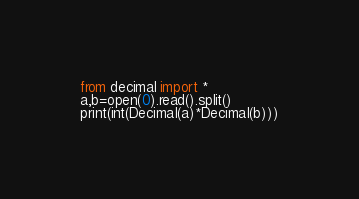<code> <loc_0><loc_0><loc_500><loc_500><_Python_>from decimal import *
a,b=open(0).read().split()
print(int(Decimal(a)*Decimal(b)))</code> 